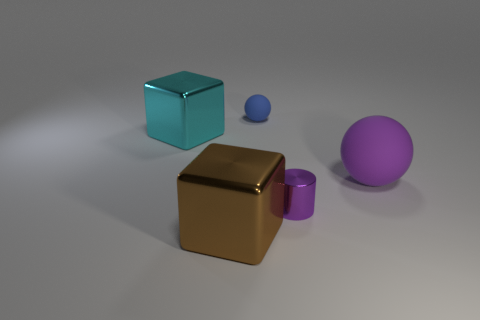Add 5 yellow cylinders. How many objects exist? 10 Subtract all cubes. How many objects are left? 3 Subtract 0 cyan balls. How many objects are left? 5 Subtract all big cyan metallic blocks. Subtract all spheres. How many objects are left? 2 Add 4 large purple things. How many large purple things are left? 5 Add 1 large blue cylinders. How many large blue cylinders exist? 1 